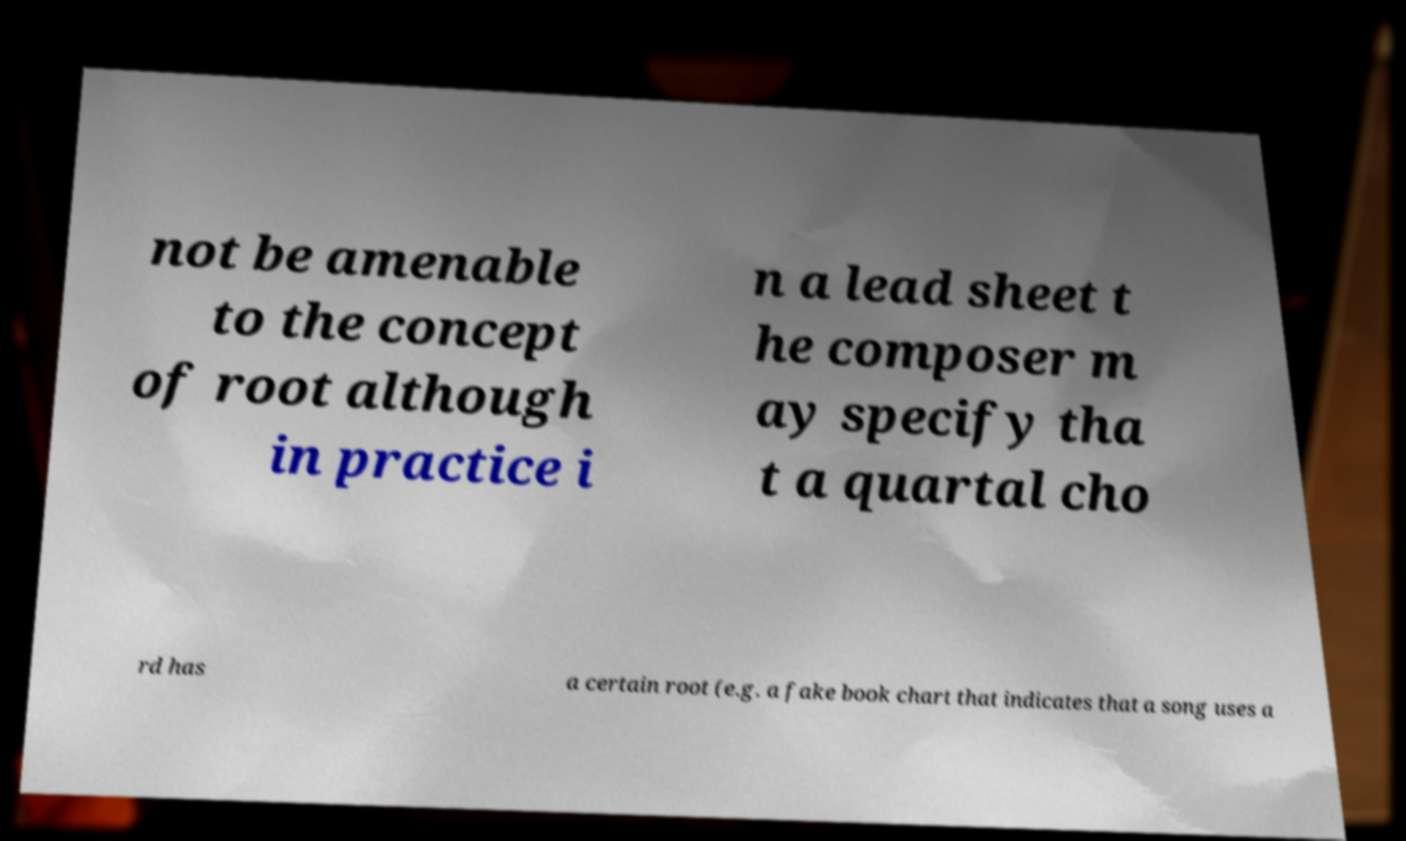I need the written content from this picture converted into text. Can you do that? not be amenable to the concept of root although in practice i n a lead sheet t he composer m ay specify tha t a quartal cho rd has a certain root (e.g. a fake book chart that indicates that a song uses a 